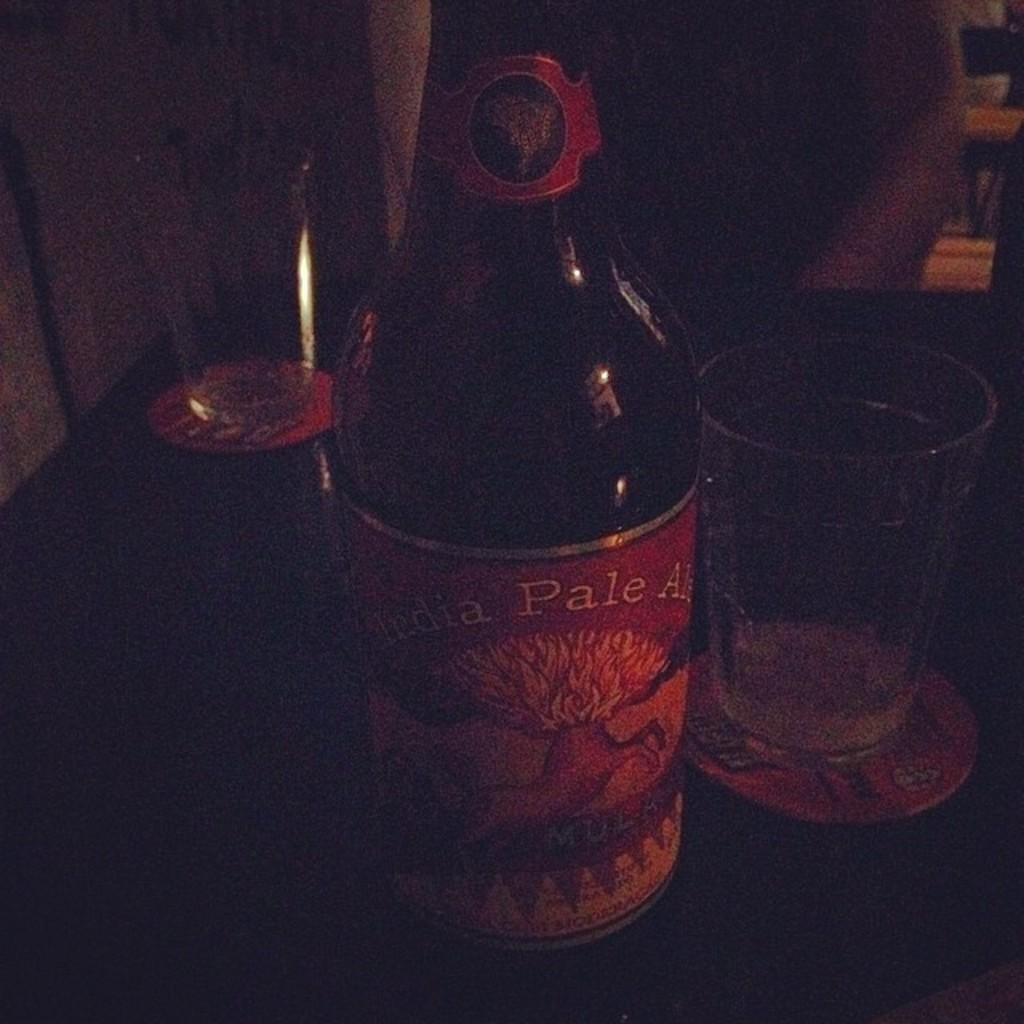What is the main object in the center of the image? There is a bottle in the center of the image. What else can be seen on the table in the image? There are two glasses on the table. What type of news is being reported by the pickle in the image? There is no pickle present in the image, and therefore no news can be reported by it. 